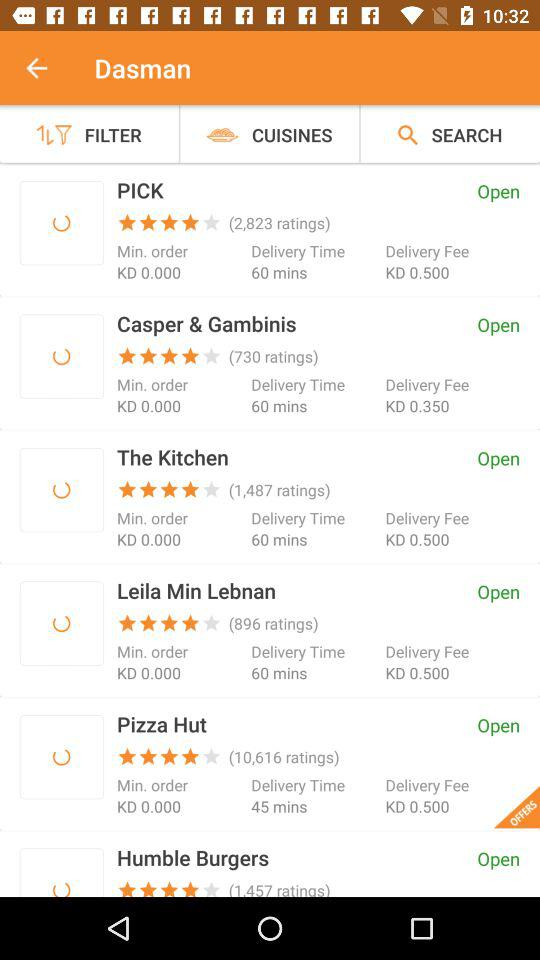What is the application's name?
When the provided information is insufficient, respond with <no answer>. <no answer> 